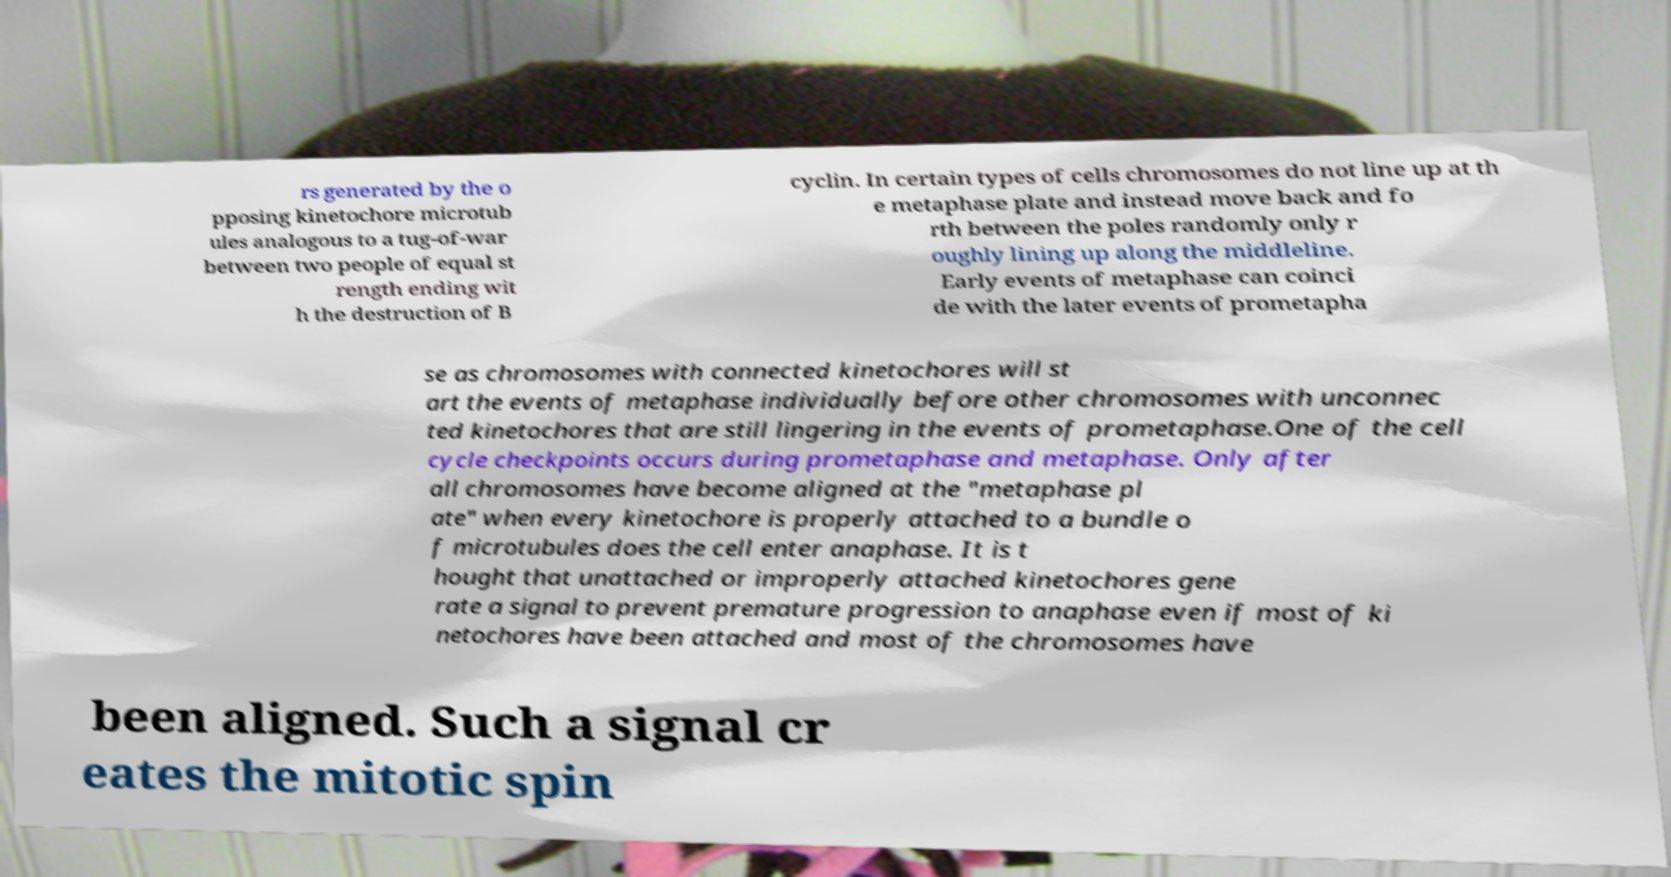Please identify and transcribe the text found in this image. rs generated by the o pposing kinetochore microtub ules analogous to a tug-of-war between two people of equal st rength ending wit h the destruction of B cyclin. In certain types of cells chromosomes do not line up at th e metaphase plate and instead move back and fo rth between the poles randomly only r oughly lining up along the middleline. Early events of metaphase can coinci de with the later events of prometapha se as chromosomes with connected kinetochores will st art the events of metaphase individually before other chromosomes with unconnec ted kinetochores that are still lingering in the events of prometaphase.One of the cell cycle checkpoints occurs during prometaphase and metaphase. Only after all chromosomes have become aligned at the "metaphase pl ate" when every kinetochore is properly attached to a bundle o f microtubules does the cell enter anaphase. It is t hought that unattached or improperly attached kinetochores gene rate a signal to prevent premature progression to anaphase even if most of ki netochores have been attached and most of the chromosomes have been aligned. Such a signal cr eates the mitotic spin 